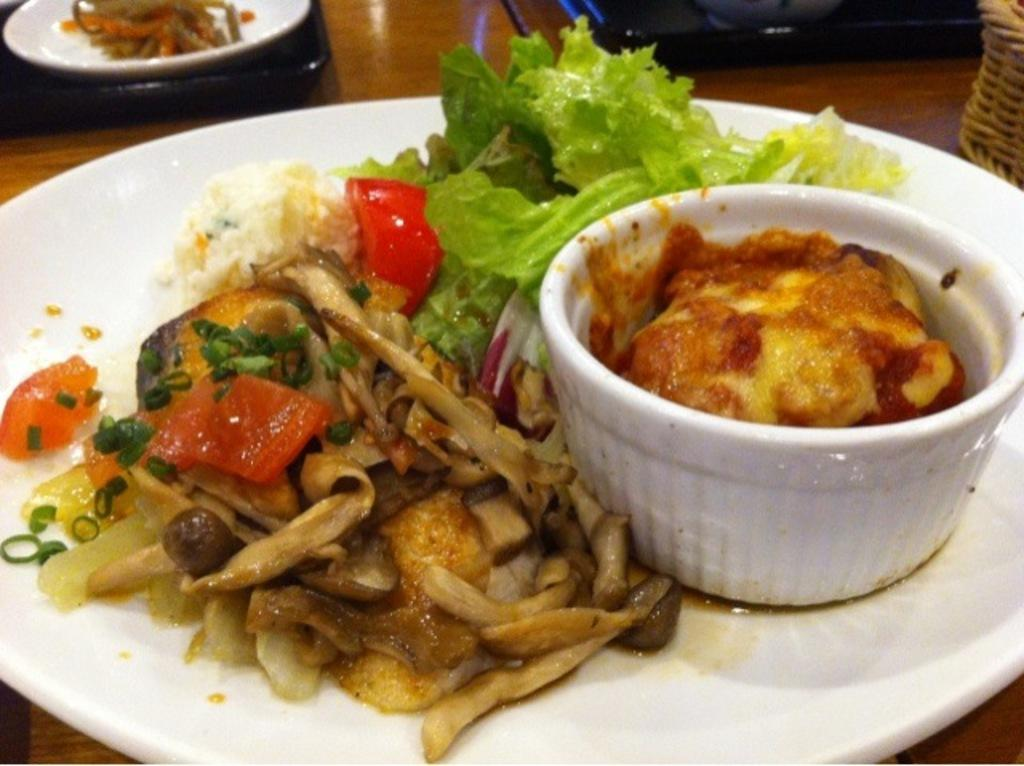What is located in the center of the image? There is a bowl and a plate containing food in the center of the image. What type of food is on the plate in the center of the image? The provided facts do not specify the type of food on the plate. What else can be seen on the table in the background? There are other food items placed on the table in the background. How many cars are parked next to the table in the image? There is no mention of cars in the image; it only features a bowl, a plate containing food, and other food items on the table. 